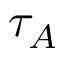Convert formula to latex. <formula><loc_0><loc_0><loc_500><loc_500>\tau _ { A }</formula> 